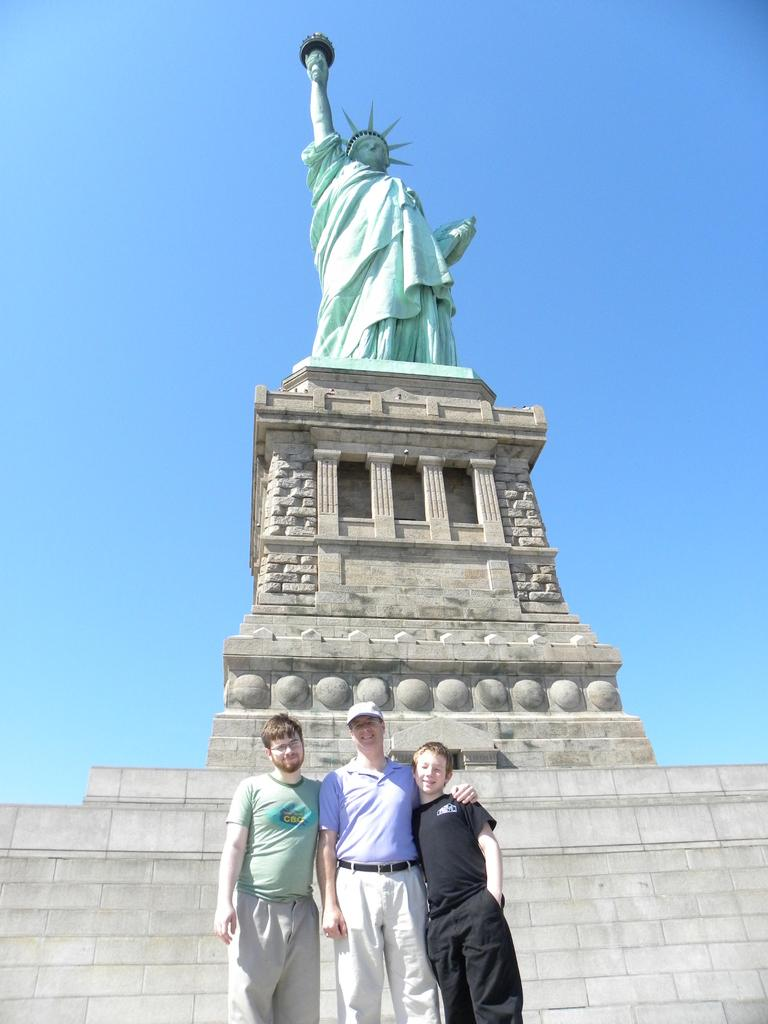What is the main subject of the image? The main subject of the image is a statue of liberty on a pillar. What are the people in the image doing? The people in the image are standing near a wall. What can be seen in the background of the image? There is a wall visible in the background of the image. What type of copper butter is being used by the grandfather in the image? There is no grandfather, copper, or butter present in the image. 